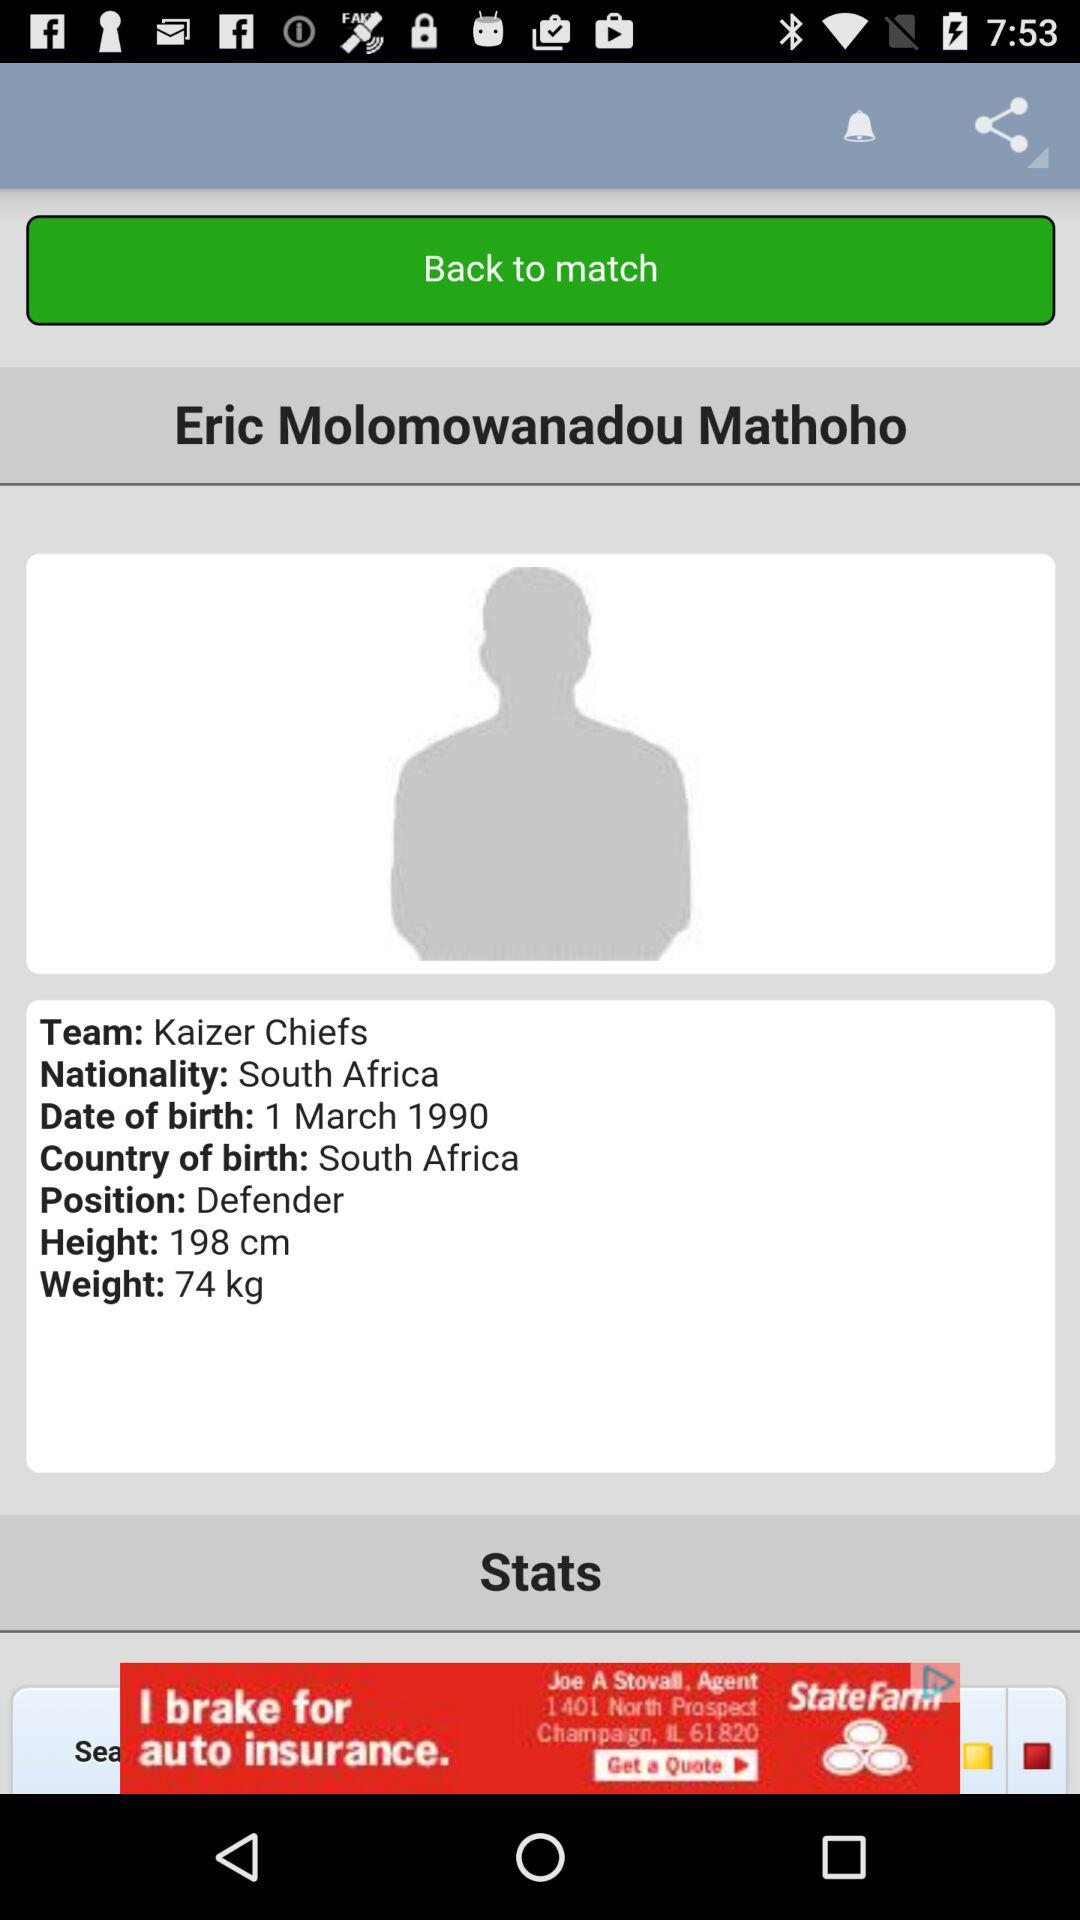What is the weight of the player? The weight of the player is 74 kg. 